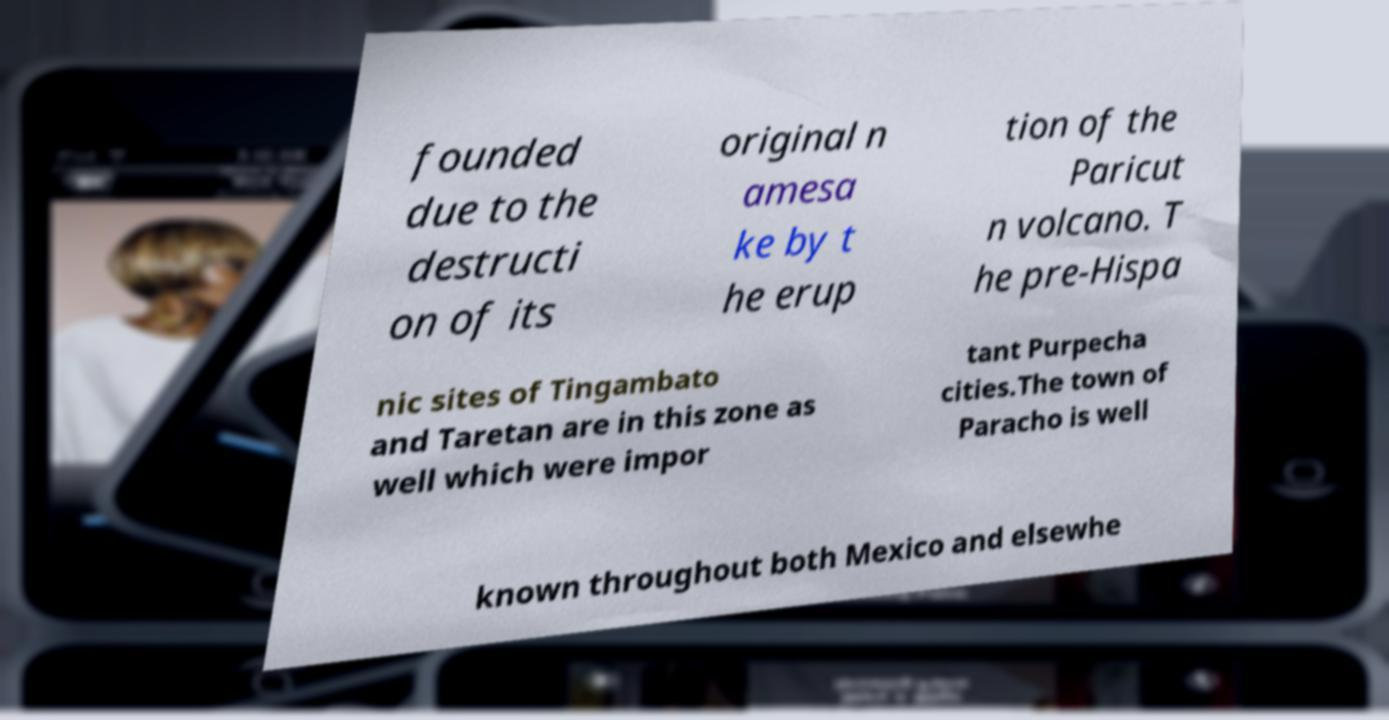For documentation purposes, I need the text within this image transcribed. Could you provide that? founded due to the destructi on of its original n amesa ke by t he erup tion of the Paricut n volcano. T he pre-Hispa nic sites of Tingambato and Taretan are in this zone as well which were impor tant Purpecha cities.The town of Paracho is well known throughout both Mexico and elsewhe 